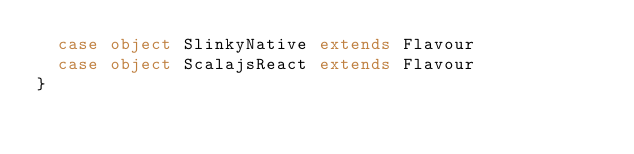Convert code to text. <code><loc_0><loc_0><loc_500><loc_500><_Scala_>  case object SlinkyNative extends Flavour
  case object ScalajsReact extends Flavour
}
</code> 